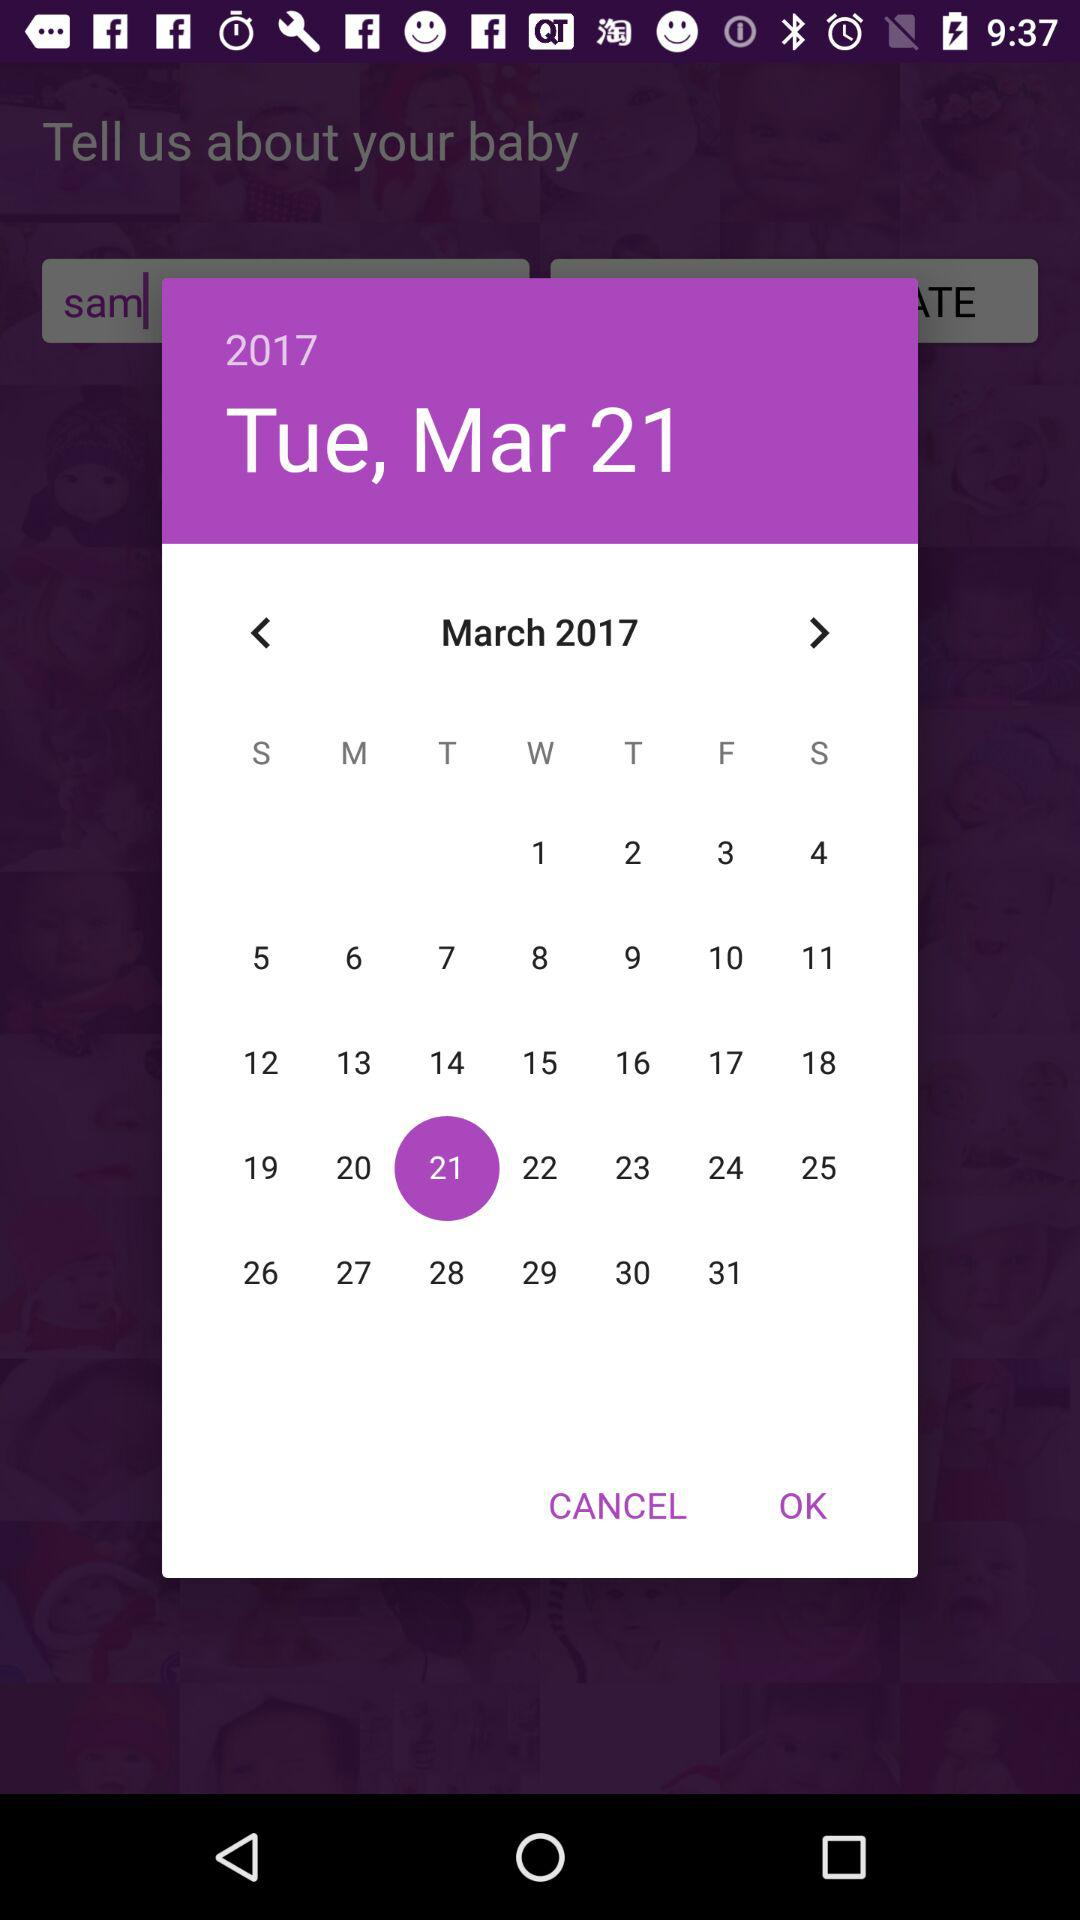What is the selected date? The selected date is Tuesday, 21st March, 2017. 